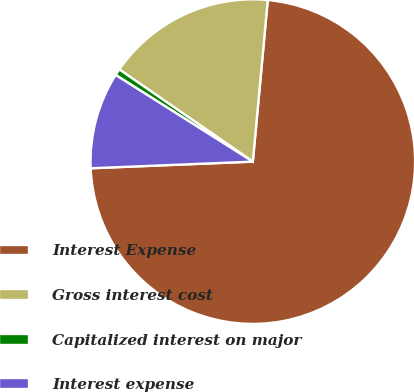Convert chart. <chart><loc_0><loc_0><loc_500><loc_500><pie_chart><fcel>Interest Expense<fcel>Gross interest cost<fcel>Capitalized interest on major<fcel>Interest expense<nl><fcel>72.88%<fcel>16.85%<fcel>0.65%<fcel>9.62%<nl></chart> 